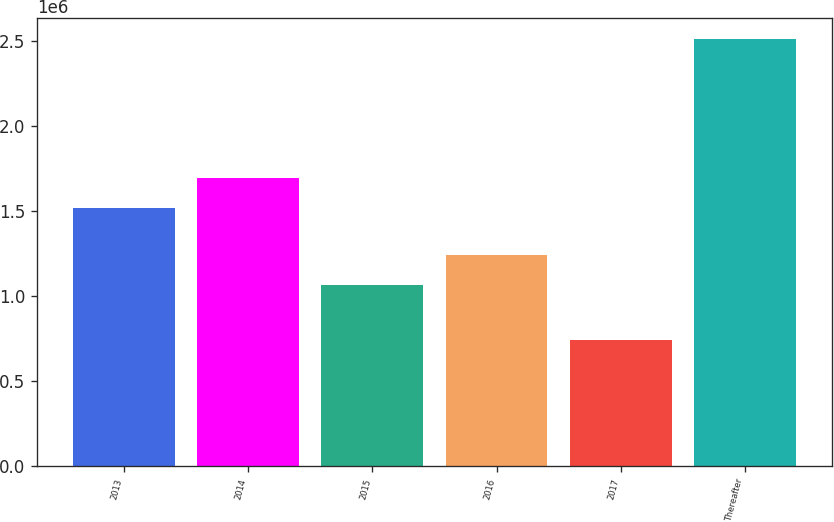Convert chart. <chart><loc_0><loc_0><loc_500><loc_500><bar_chart><fcel>2013<fcel>2014<fcel>2015<fcel>2016<fcel>2017<fcel>Thereafter<nl><fcel>1.51948e+06<fcel>1.69622e+06<fcel>1.06354e+06<fcel>1.24028e+06<fcel>744174<fcel>2.51158e+06<nl></chart> 